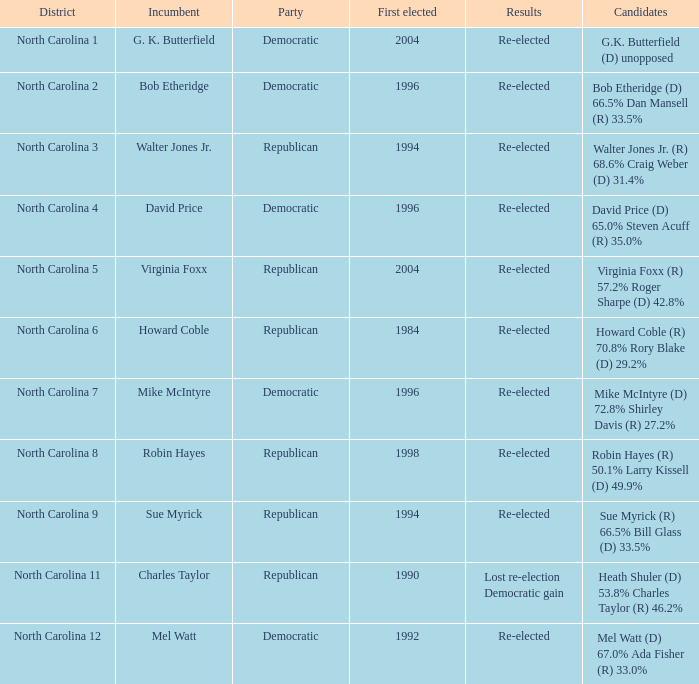How many times was Mike McIntyre elected? 1.0. 